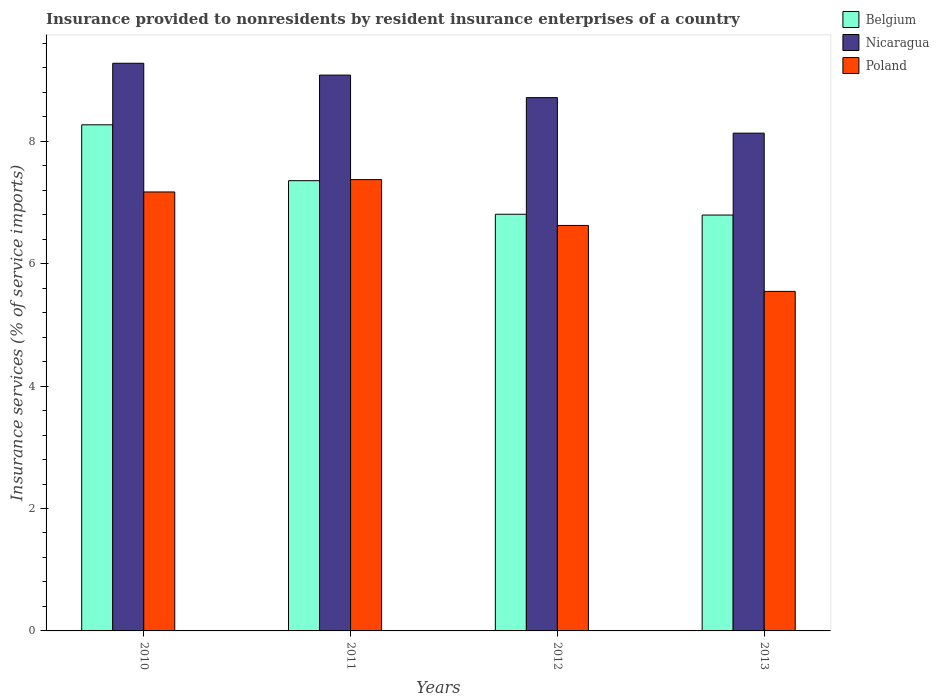How many different coloured bars are there?
Keep it short and to the point. 3. How many groups of bars are there?
Keep it short and to the point. 4. How many bars are there on the 4th tick from the left?
Your response must be concise. 3. How many bars are there on the 3rd tick from the right?
Provide a succinct answer. 3. In how many cases, is the number of bars for a given year not equal to the number of legend labels?
Provide a short and direct response. 0. What is the insurance provided to nonresidents in Poland in 2010?
Your response must be concise. 7.17. Across all years, what is the maximum insurance provided to nonresidents in Nicaragua?
Keep it short and to the point. 9.27. Across all years, what is the minimum insurance provided to nonresidents in Belgium?
Give a very brief answer. 6.79. In which year was the insurance provided to nonresidents in Poland maximum?
Ensure brevity in your answer.  2011. In which year was the insurance provided to nonresidents in Belgium minimum?
Make the answer very short. 2013. What is the total insurance provided to nonresidents in Poland in the graph?
Provide a succinct answer. 26.72. What is the difference between the insurance provided to nonresidents in Poland in 2011 and that in 2012?
Provide a succinct answer. 0.75. What is the difference between the insurance provided to nonresidents in Belgium in 2012 and the insurance provided to nonresidents in Nicaragua in 2013?
Your answer should be compact. -1.33. What is the average insurance provided to nonresidents in Belgium per year?
Your answer should be compact. 7.31. In the year 2010, what is the difference between the insurance provided to nonresidents in Belgium and insurance provided to nonresidents in Nicaragua?
Your response must be concise. -1.01. In how many years, is the insurance provided to nonresidents in Poland greater than 2.4 %?
Give a very brief answer. 4. What is the ratio of the insurance provided to nonresidents in Poland in 2010 to that in 2013?
Make the answer very short. 1.29. What is the difference between the highest and the second highest insurance provided to nonresidents in Nicaragua?
Offer a very short reply. 0.19. What is the difference between the highest and the lowest insurance provided to nonresidents in Poland?
Your answer should be compact. 1.83. Is the sum of the insurance provided to nonresidents in Poland in 2011 and 2012 greater than the maximum insurance provided to nonresidents in Belgium across all years?
Offer a very short reply. Yes. What does the 2nd bar from the left in 2010 represents?
Your response must be concise. Nicaragua. What does the 1st bar from the right in 2011 represents?
Your answer should be compact. Poland. How many bars are there?
Provide a short and direct response. 12. What is the difference between two consecutive major ticks on the Y-axis?
Your answer should be very brief. 2. Are the values on the major ticks of Y-axis written in scientific E-notation?
Keep it short and to the point. No. How are the legend labels stacked?
Ensure brevity in your answer.  Vertical. What is the title of the graph?
Ensure brevity in your answer.  Insurance provided to nonresidents by resident insurance enterprises of a country. What is the label or title of the X-axis?
Provide a short and direct response. Years. What is the label or title of the Y-axis?
Provide a succinct answer. Insurance services (% of service imports). What is the Insurance services (% of service imports) of Belgium in 2010?
Offer a terse response. 8.27. What is the Insurance services (% of service imports) in Nicaragua in 2010?
Provide a short and direct response. 9.27. What is the Insurance services (% of service imports) of Poland in 2010?
Offer a very short reply. 7.17. What is the Insurance services (% of service imports) of Belgium in 2011?
Your answer should be compact. 7.36. What is the Insurance services (% of service imports) in Nicaragua in 2011?
Your answer should be compact. 9.08. What is the Insurance services (% of service imports) in Poland in 2011?
Ensure brevity in your answer.  7.37. What is the Insurance services (% of service imports) of Belgium in 2012?
Provide a succinct answer. 6.81. What is the Insurance services (% of service imports) of Nicaragua in 2012?
Offer a very short reply. 8.71. What is the Insurance services (% of service imports) of Poland in 2012?
Provide a short and direct response. 6.62. What is the Insurance services (% of service imports) of Belgium in 2013?
Ensure brevity in your answer.  6.79. What is the Insurance services (% of service imports) of Nicaragua in 2013?
Your answer should be compact. 8.13. What is the Insurance services (% of service imports) in Poland in 2013?
Provide a succinct answer. 5.55. Across all years, what is the maximum Insurance services (% of service imports) in Belgium?
Give a very brief answer. 8.27. Across all years, what is the maximum Insurance services (% of service imports) of Nicaragua?
Provide a succinct answer. 9.27. Across all years, what is the maximum Insurance services (% of service imports) of Poland?
Offer a very short reply. 7.37. Across all years, what is the minimum Insurance services (% of service imports) in Belgium?
Offer a terse response. 6.79. Across all years, what is the minimum Insurance services (% of service imports) of Nicaragua?
Make the answer very short. 8.13. Across all years, what is the minimum Insurance services (% of service imports) of Poland?
Ensure brevity in your answer.  5.55. What is the total Insurance services (% of service imports) in Belgium in the graph?
Make the answer very short. 29.23. What is the total Insurance services (% of service imports) in Nicaragua in the graph?
Your answer should be compact. 35.2. What is the total Insurance services (% of service imports) in Poland in the graph?
Offer a terse response. 26.72. What is the difference between the Insurance services (% of service imports) in Belgium in 2010 and that in 2011?
Your answer should be compact. 0.91. What is the difference between the Insurance services (% of service imports) in Nicaragua in 2010 and that in 2011?
Offer a terse response. 0.19. What is the difference between the Insurance services (% of service imports) of Poland in 2010 and that in 2011?
Give a very brief answer. -0.2. What is the difference between the Insurance services (% of service imports) of Belgium in 2010 and that in 2012?
Provide a succinct answer. 1.46. What is the difference between the Insurance services (% of service imports) of Nicaragua in 2010 and that in 2012?
Ensure brevity in your answer.  0.56. What is the difference between the Insurance services (% of service imports) of Poland in 2010 and that in 2012?
Provide a succinct answer. 0.55. What is the difference between the Insurance services (% of service imports) in Belgium in 2010 and that in 2013?
Make the answer very short. 1.47. What is the difference between the Insurance services (% of service imports) in Nicaragua in 2010 and that in 2013?
Provide a short and direct response. 1.14. What is the difference between the Insurance services (% of service imports) of Poland in 2010 and that in 2013?
Offer a very short reply. 1.62. What is the difference between the Insurance services (% of service imports) in Belgium in 2011 and that in 2012?
Provide a short and direct response. 0.55. What is the difference between the Insurance services (% of service imports) of Nicaragua in 2011 and that in 2012?
Ensure brevity in your answer.  0.37. What is the difference between the Insurance services (% of service imports) of Poland in 2011 and that in 2012?
Give a very brief answer. 0.75. What is the difference between the Insurance services (% of service imports) of Belgium in 2011 and that in 2013?
Provide a succinct answer. 0.56. What is the difference between the Insurance services (% of service imports) of Nicaragua in 2011 and that in 2013?
Offer a terse response. 0.95. What is the difference between the Insurance services (% of service imports) of Poland in 2011 and that in 2013?
Give a very brief answer. 1.83. What is the difference between the Insurance services (% of service imports) in Belgium in 2012 and that in 2013?
Ensure brevity in your answer.  0.01. What is the difference between the Insurance services (% of service imports) in Nicaragua in 2012 and that in 2013?
Offer a very short reply. 0.58. What is the difference between the Insurance services (% of service imports) of Poland in 2012 and that in 2013?
Give a very brief answer. 1.08. What is the difference between the Insurance services (% of service imports) in Belgium in 2010 and the Insurance services (% of service imports) in Nicaragua in 2011?
Keep it short and to the point. -0.81. What is the difference between the Insurance services (% of service imports) in Belgium in 2010 and the Insurance services (% of service imports) in Poland in 2011?
Keep it short and to the point. 0.9. What is the difference between the Insurance services (% of service imports) in Nicaragua in 2010 and the Insurance services (% of service imports) in Poland in 2011?
Your answer should be very brief. 1.9. What is the difference between the Insurance services (% of service imports) of Belgium in 2010 and the Insurance services (% of service imports) of Nicaragua in 2012?
Your answer should be compact. -0.44. What is the difference between the Insurance services (% of service imports) of Belgium in 2010 and the Insurance services (% of service imports) of Poland in 2012?
Offer a very short reply. 1.64. What is the difference between the Insurance services (% of service imports) of Nicaragua in 2010 and the Insurance services (% of service imports) of Poland in 2012?
Ensure brevity in your answer.  2.65. What is the difference between the Insurance services (% of service imports) of Belgium in 2010 and the Insurance services (% of service imports) of Nicaragua in 2013?
Provide a succinct answer. 0.14. What is the difference between the Insurance services (% of service imports) of Belgium in 2010 and the Insurance services (% of service imports) of Poland in 2013?
Provide a short and direct response. 2.72. What is the difference between the Insurance services (% of service imports) of Nicaragua in 2010 and the Insurance services (% of service imports) of Poland in 2013?
Provide a short and direct response. 3.73. What is the difference between the Insurance services (% of service imports) of Belgium in 2011 and the Insurance services (% of service imports) of Nicaragua in 2012?
Your response must be concise. -1.36. What is the difference between the Insurance services (% of service imports) in Belgium in 2011 and the Insurance services (% of service imports) in Poland in 2012?
Offer a very short reply. 0.73. What is the difference between the Insurance services (% of service imports) of Nicaragua in 2011 and the Insurance services (% of service imports) of Poland in 2012?
Keep it short and to the point. 2.46. What is the difference between the Insurance services (% of service imports) in Belgium in 2011 and the Insurance services (% of service imports) in Nicaragua in 2013?
Make the answer very short. -0.78. What is the difference between the Insurance services (% of service imports) in Belgium in 2011 and the Insurance services (% of service imports) in Poland in 2013?
Your answer should be very brief. 1.81. What is the difference between the Insurance services (% of service imports) of Nicaragua in 2011 and the Insurance services (% of service imports) of Poland in 2013?
Provide a succinct answer. 3.53. What is the difference between the Insurance services (% of service imports) of Belgium in 2012 and the Insurance services (% of service imports) of Nicaragua in 2013?
Your response must be concise. -1.32. What is the difference between the Insurance services (% of service imports) in Belgium in 2012 and the Insurance services (% of service imports) in Poland in 2013?
Provide a short and direct response. 1.26. What is the difference between the Insurance services (% of service imports) of Nicaragua in 2012 and the Insurance services (% of service imports) of Poland in 2013?
Make the answer very short. 3.17. What is the average Insurance services (% of service imports) in Belgium per year?
Your response must be concise. 7.31. What is the average Insurance services (% of service imports) in Nicaragua per year?
Your answer should be very brief. 8.8. What is the average Insurance services (% of service imports) of Poland per year?
Keep it short and to the point. 6.68. In the year 2010, what is the difference between the Insurance services (% of service imports) in Belgium and Insurance services (% of service imports) in Nicaragua?
Ensure brevity in your answer.  -1.01. In the year 2010, what is the difference between the Insurance services (% of service imports) of Belgium and Insurance services (% of service imports) of Poland?
Offer a terse response. 1.1. In the year 2010, what is the difference between the Insurance services (% of service imports) in Nicaragua and Insurance services (% of service imports) in Poland?
Your response must be concise. 2.1. In the year 2011, what is the difference between the Insurance services (% of service imports) of Belgium and Insurance services (% of service imports) of Nicaragua?
Provide a succinct answer. -1.73. In the year 2011, what is the difference between the Insurance services (% of service imports) of Belgium and Insurance services (% of service imports) of Poland?
Give a very brief answer. -0.02. In the year 2011, what is the difference between the Insurance services (% of service imports) in Nicaragua and Insurance services (% of service imports) in Poland?
Offer a very short reply. 1.71. In the year 2012, what is the difference between the Insurance services (% of service imports) in Belgium and Insurance services (% of service imports) in Nicaragua?
Make the answer very short. -1.91. In the year 2012, what is the difference between the Insurance services (% of service imports) of Belgium and Insurance services (% of service imports) of Poland?
Provide a succinct answer. 0.18. In the year 2012, what is the difference between the Insurance services (% of service imports) of Nicaragua and Insurance services (% of service imports) of Poland?
Offer a very short reply. 2.09. In the year 2013, what is the difference between the Insurance services (% of service imports) in Belgium and Insurance services (% of service imports) in Nicaragua?
Provide a short and direct response. -1.34. In the year 2013, what is the difference between the Insurance services (% of service imports) in Belgium and Insurance services (% of service imports) in Poland?
Keep it short and to the point. 1.25. In the year 2013, what is the difference between the Insurance services (% of service imports) in Nicaragua and Insurance services (% of service imports) in Poland?
Your response must be concise. 2.59. What is the ratio of the Insurance services (% of service imports) in Belgium in 2010 to that in 2011?
Provide a short and direct response. 1.12. What is the ratio of the Insurance services (% of service imports) of Nicaragua in 2010 to that in 2011?
Offer a very short reply. 1.02. What is the ratio of the Insurance services (% of service imports) in Poland in 2010 to that in 2011?
Your response must be concise. 0.97. What is the ratio of the Insurance services (% of service imports) of Belgium in 2010 to that in 2012?
Your response must be concise. 1.21. What is the ratio of the Insurance services (% of service imports) of Nicaragua in 2010 to that in 2012?
Offer a terse response. 1.06. What is the ratio of the Insurance services (% of service imports) of Poland in 2010 to that in 2012?
Provide a short and direct response. 1.08. What is the ratio of the Insurance services (% of service imports) of Belgium in 2010 to that in 2013?
Provide a succinct answer. 1.22. What is the ratio of the Insurance services (% of service imports) in Nicaragua in 2010 to that in 2013?
Provide a succinct answer. 1.14. What is the ratio of the Insurance services (% of service imports) in Poland in 2010 to that in 2013?
Keep it short and to the point. 1.29. What is the ratio of the Insurance services (% of service imports) in Belgium in 2011 to that in 2012?
Offer a very short reply. 1.08. What is the ratio of the Insurance services (% of service imports) of Nicaragua in 2011 to that in 2012?
Give a very brief answer. 1.04. What is the ratio of the Insurance services (% of service imports) in Poland in 2011 to that in 2012?
Give a very brief answer. 1.11. What is the ratio of the Insurance services (% of service imports) of Belgium in 2011 to that in 2013?
Your response must be concise. 1.08. What is the ratio of the Insurance services (% of service imports) in Nicaragua in 2011 to that in 2013?
Keep it short and to the point. 1.12. What is the ratio of the Insurance services (% of service imports) of Poland in 2011 to that in 2013?
Your answer should be very brief. 1.33. What is the ratio of the Insurance services (% of service imports) of Nicaragua in 2012 to that in 2013?
Your answer should be very brief. 1.07. What is the ratio of the Insurance services (% of service imports) in Poland in 2012 to that in 2013?
Provide a short and direct response. 1.19. What is the difference between the highest and the second highest Insurance services (% of service imports) in Belgium?
Give a very brief answer. 0.91. What is the difference between the highest and the second highest Insurance services (% of service imports) of Nicaragua?
Provide a short and direct response. 0.19. What is the difference between the highest and the second highest Insurance services (% of service imports) of Poland?
Offer a terse response. 0.2. What is the difference between the highest and the lowest Insurance services (% of service imports) in Belgium?
Offer a terse response. 1.47. What is the difference between the highest and the lowest Insurance services (% of service imports) in Nicaragua?
Your answer should be compact. 1.14. What is the difference between the highest and the lowest Insurance services (% of service imports) in Poland?
Make the answer very short. 1.83. 